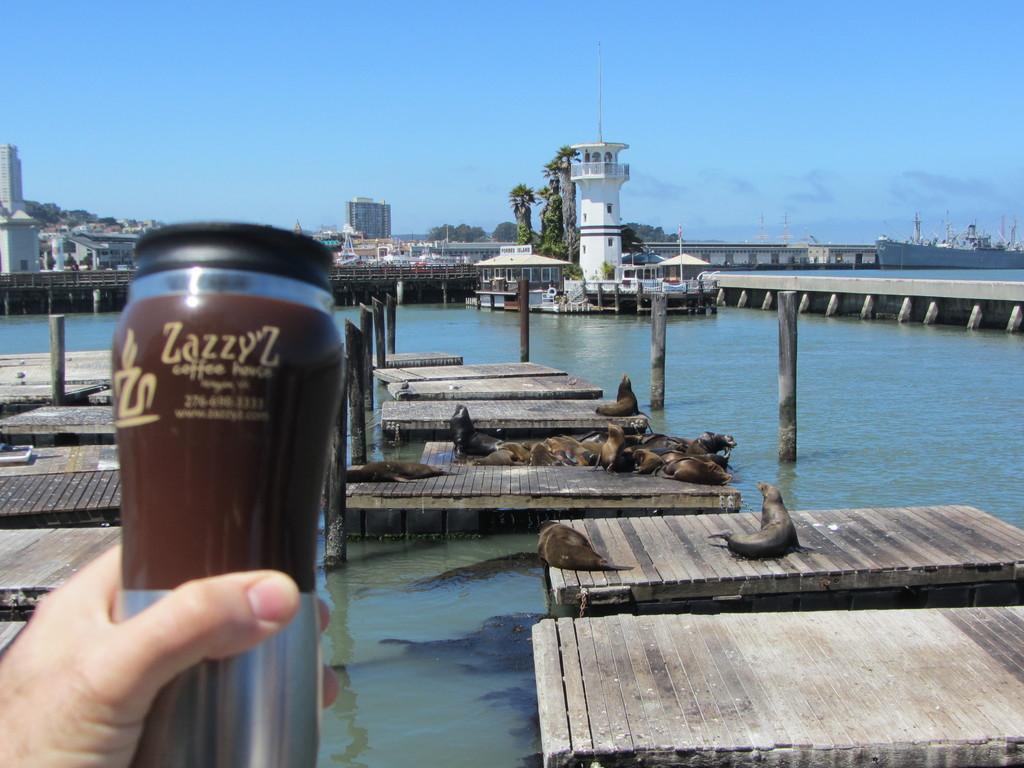Can you describe this image briefly? In this image there is a person holding an object , there are seals on the wooden piers ,there is a ship on the water ,there is a bridge, and there are buildings, trees, and in the background there is sky. 